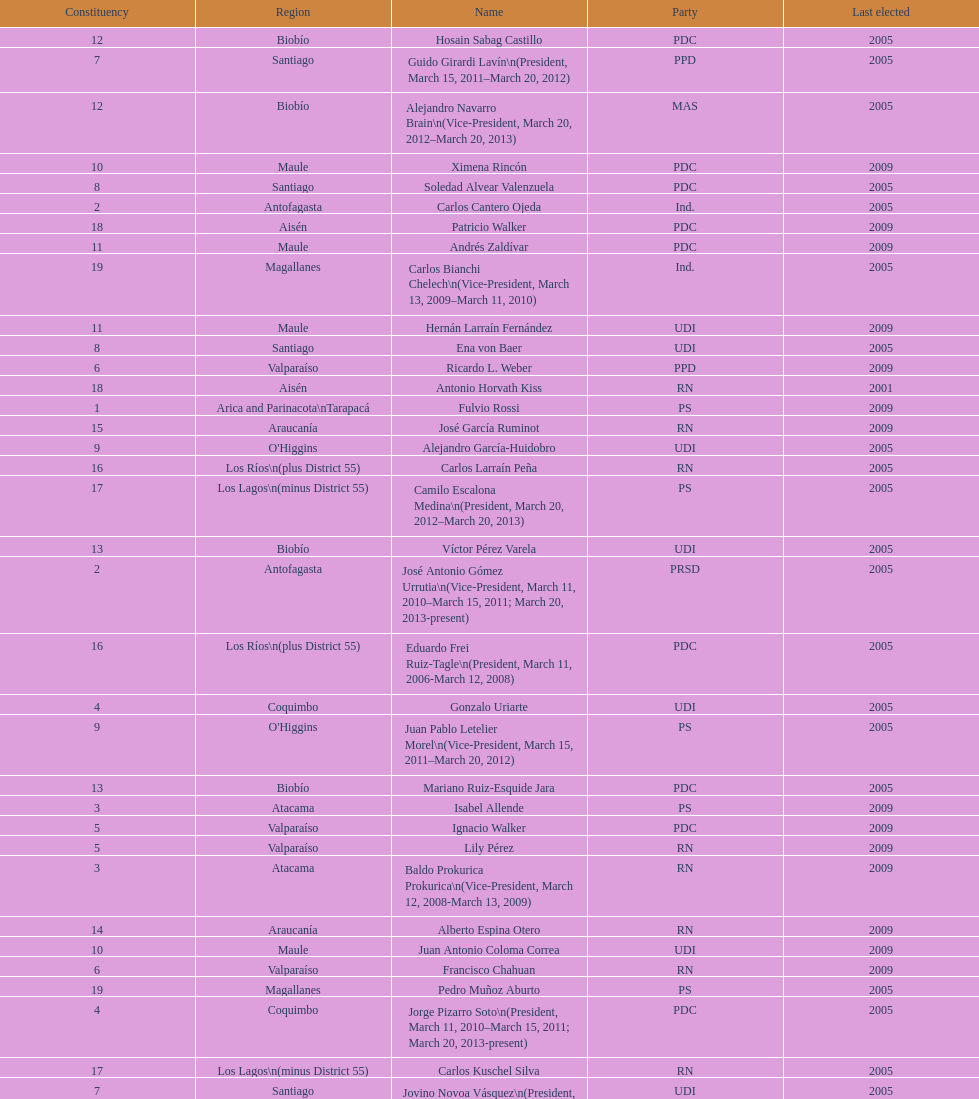How long was baldo prokurica prokurica vice-president? 1 year. 